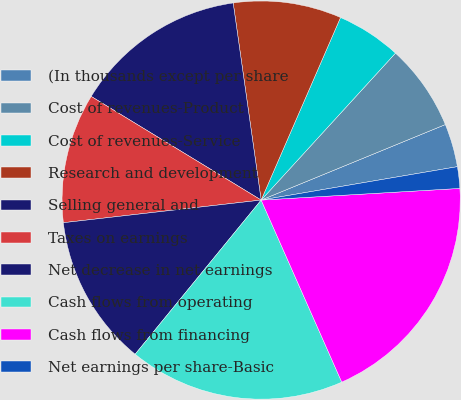<chart> <loc_0><loc_0><loc_500><loc_500><pie_chart><fcel>(In thousands except per share<fcel>Cost of revenues-Product<fcel>Cost of revenues-Service<fcel>Research and development<fcel>Selling general and<fcel>Taxes on earnings<fcel>Net decrease in net earnings<fcel>Cash flows from operating<fcel>Cash flows from financing<fcel>Net earnings per share-Basic<nl><fcel>3.51%<fcel>7.02%<fcel>5.26%<fcel>8.77%<fcel>14.04%<fcel>10.53%<fcel>12.28%<fcel>17.54%<fcel>19.3%<fcel>1.75%<nl></chart> 